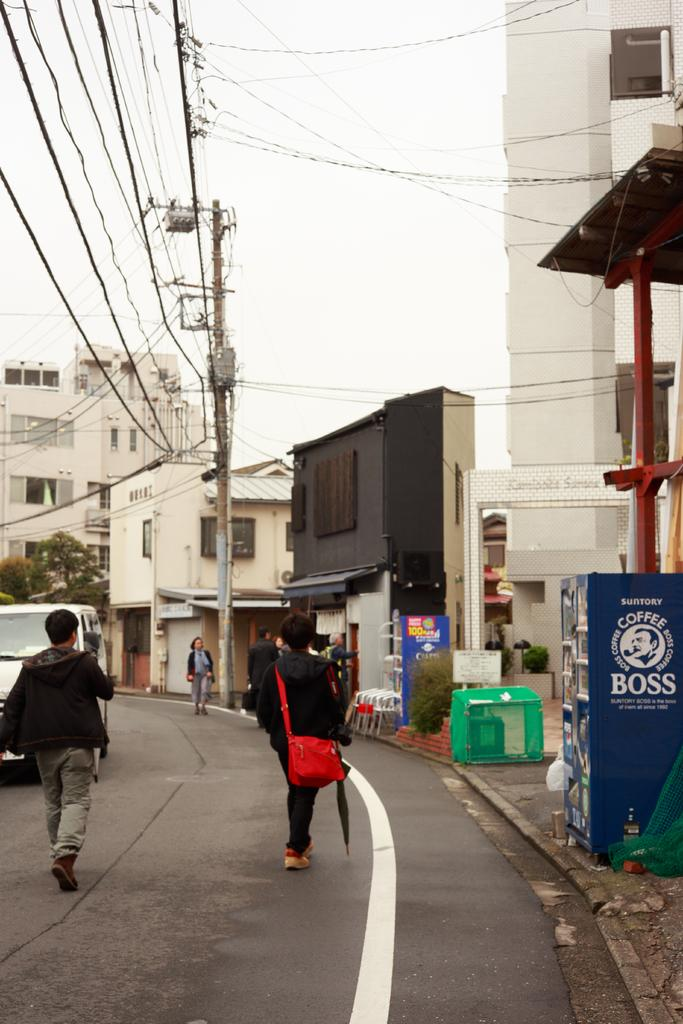What is the main subject of the image? There is a vehicle in the image. What else can be seen in the image besides the vehicle? There are people on the road, buildings, trees, plants, a pole, wires, and the sky visible in the background of the image. Can you describe the surroundings of the vehicle? The vehicle is on a road with people, and there are buildings, trees, plants, a pole, wires, and the sky in the background. What type of objects are present on the pole in the background? The facts provided do not specify what objects are on the pole, so we cannot answer that question. How many fingers can be seen on the spot in the image? There is no spot or fingers mentioned in the image, so we cannot answer that question. 